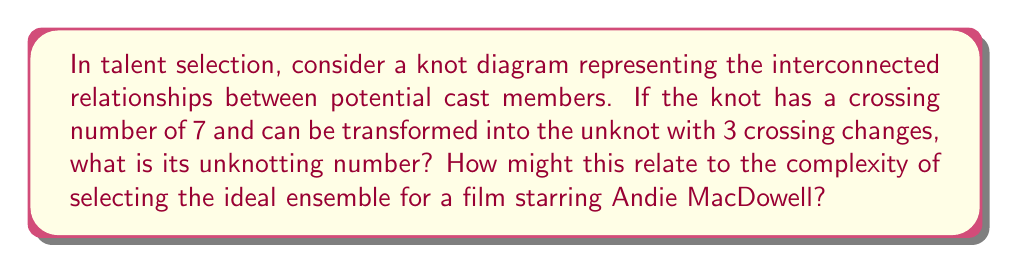Help me with this question. To solve this problem, we need to understand the concept of unknotting number and its implications in talent selection:

1. The unknotting number $u(K)$ of a knot $K$ is the minimum number of crossing changes required to transform the knot into the unknot (trivial knot).

2. Given information:
   - Crossing number of the knot = 7
   - Number of crossing changes to unknot = 3

3. The unknotting number is always less than or equal to the number of crossing changes needed to unknot the knot. Therefore:

   $$u(K) \leq 3$$

4. The unknotting number is also always less than or equal to half the crossing number:

   $$u(K) \leq \frac{c(K)}{2} = \frac{7}{2} = 3.5$$

5. Since we know that 3 crossing changes are sufficient to unknot the knot, and this satisfies both conditions above, we can conclude that the unknotting number is indeed 3.

Relating this to talent selection:
- The knot represents the complex network of relationships and interactions between potential cast members.
- The crossing number (7) represents the total number of significant interactions or conflicts to consider.
- The unknotting number (3) represents the minimum number of crucial decisions or adjustments needed to create a harmonious ensemble.
- This implies that while there are many factors to consider (7 crossings), focusing on resolving just 3 key issues can lead to a well-functioning cast, potentially simplifying the selection process for a film starring Andie MacDowell.
Answer: $u(K) = 3$ 